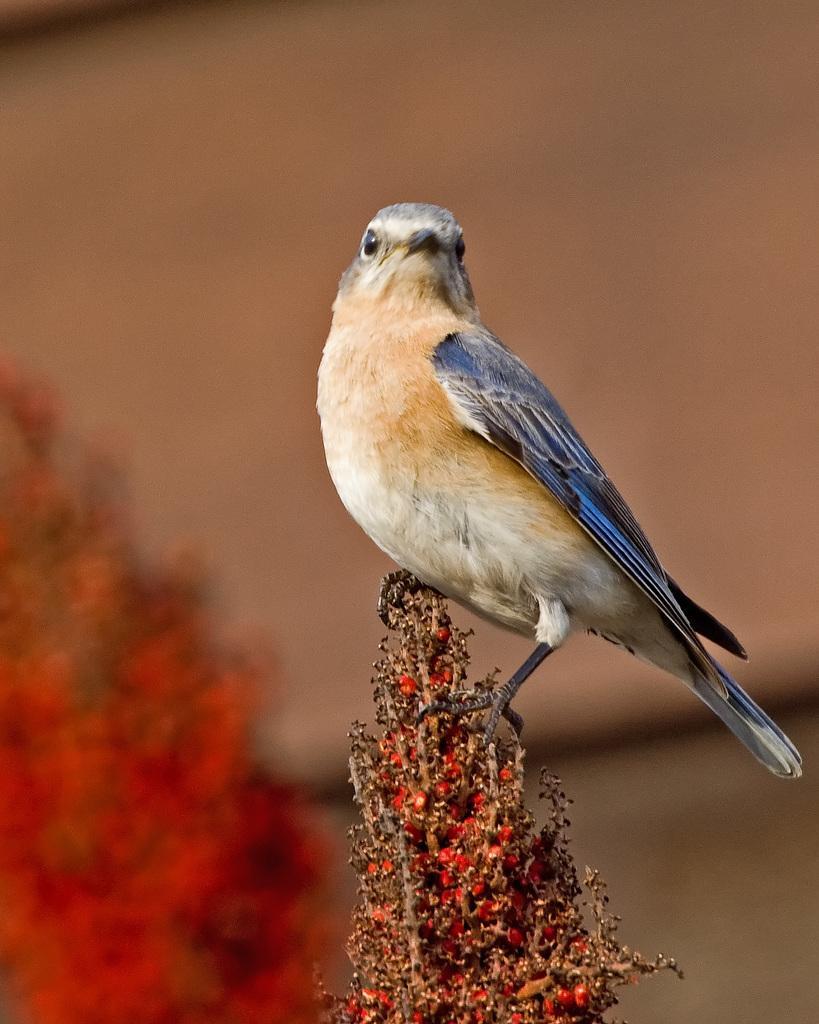Please provide a concise description of this image. In this image we can see a bird on the plant. 